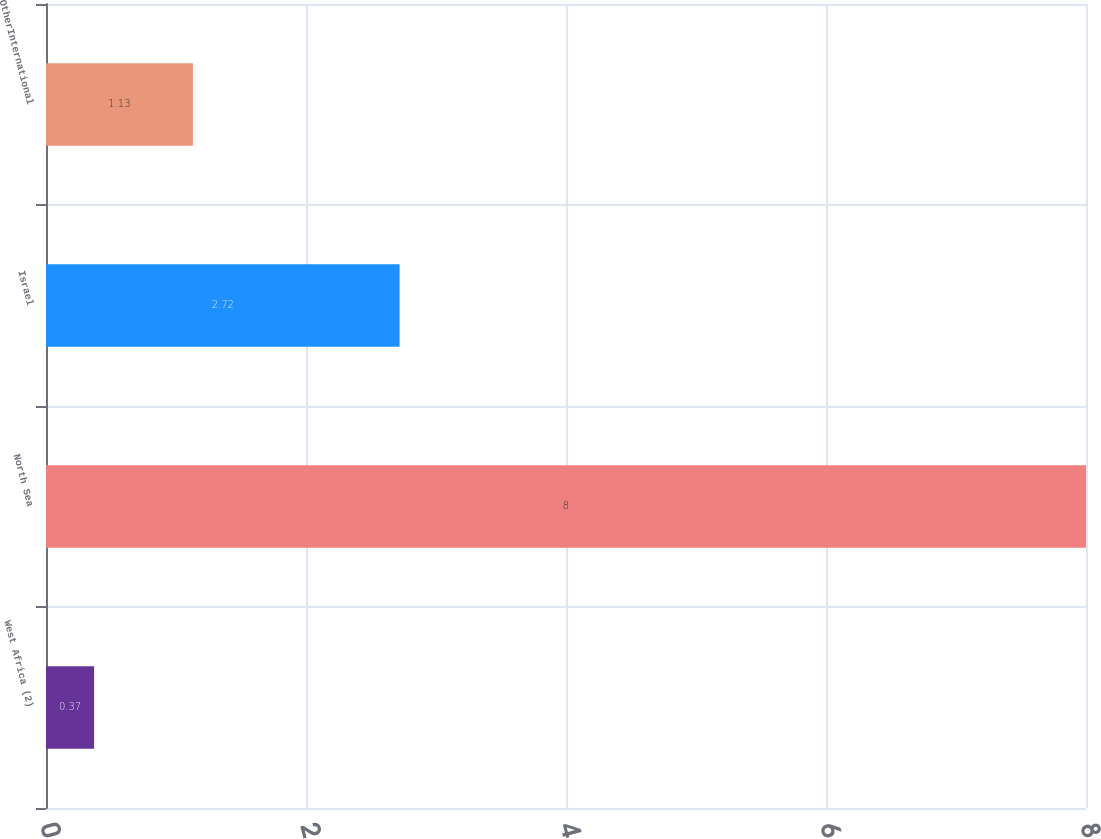<chart> <loc_0><loc_0><loc_500><loc_500><bar_chart><fcel>West Africa (2)<fcel>North Sea<fcel>Israel<fcel>OtherInternational<nl><fcel>0.37<fcel>8<fcel>2.72<fcel>1.13<nl></chart> 